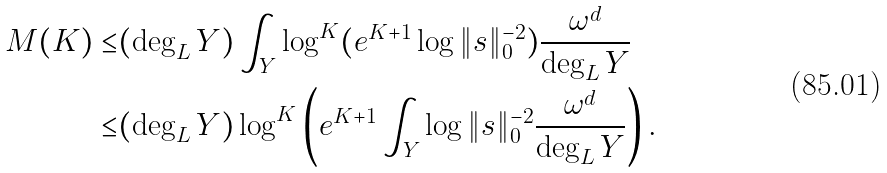<formula> <loc_0><loc_0><loc_500><loc_500>M ( K ) \leq & ( \deg _ { L } Y ) \int _ { Y } \log ^ { K } ( e ^ { K + 1 } \log \| s \| _ { 0 } ^ { - 2 } ) \frac { \omega ^ { d } } { \deg _ { L } Y } \\ \leq & ( \deg _ { L } Y ) \log ^ { K } \left ( e ^ { K + 1 } \int _ { Y } \log \| s \| _ { 0 } ^ { - 2 } \frac { \omega ^ { d } } { \deg _ { L } Y } \right ) .</formula> 